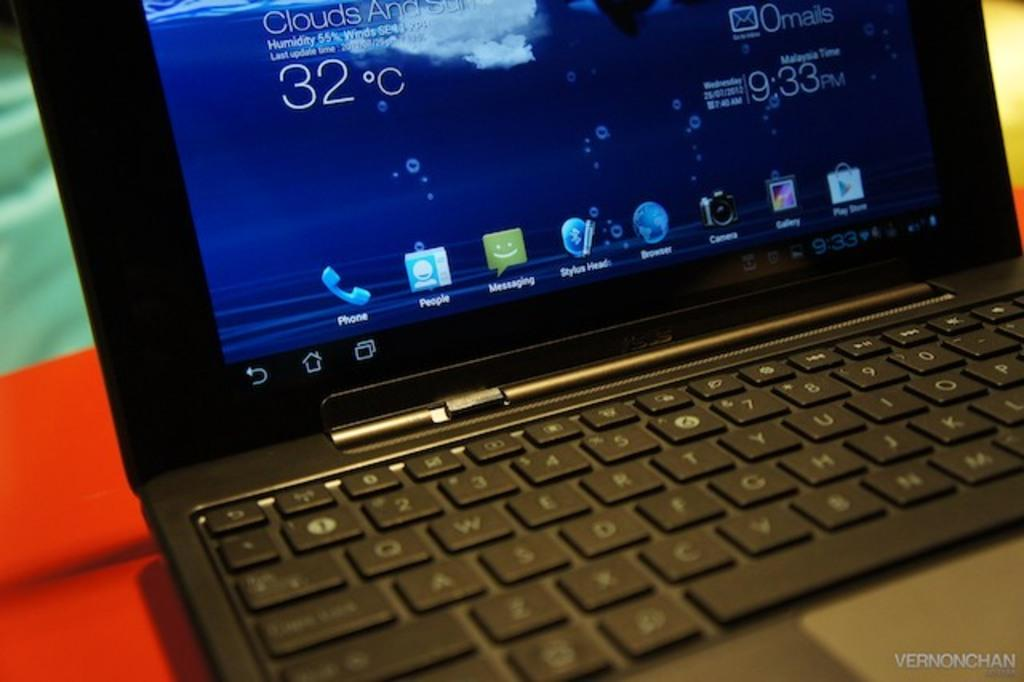<image>
Relay a brief, clear account of the picture shown. A black laptop has the word Phone under an icon of a handset on its screen. 